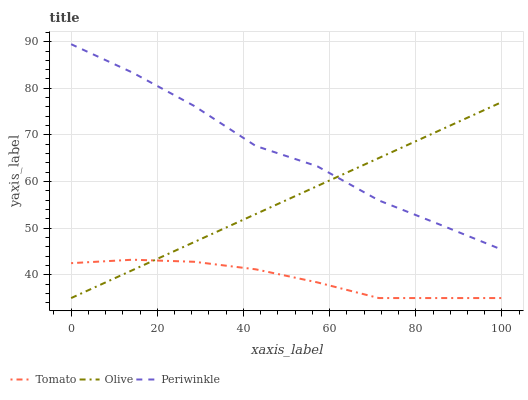Does Tomato have the minimum area under the curve?
Answer yes or no. Yes. Does Periwinkle have the maximum area under the curve?
Answer yes or no. Yes. Does Olive have the minimum area under the curve?
Answer yes or no. No. Does Olive have the maximum area under the curve?
Answer yes or no. No. Is Olive the smoothest?
Answer yes or no. Yes. Is Periwinkle the roughest?
Answer yes or no. Yes. Is Periwinkle the smoothest?
Answer yes or no. No. Is Olive the roughest?
Answer yes or no. No. Does Tomato have the lowest value?
Answer yes or no. Yes. Does Periwinkle have the lowest value?
Answer yes or no. No. Does Periwinkle have the highest value?
Answer yes or no. Yes. Does Olive have the highest value?
Answer yes or no. No. Is Tomato less than Periwinkle?
Answer yes or no. Yes. Is Periwinkle greater than Tomato?
Answer yes or no. Yes. Does Olive intersect Tomato?
Answer yes or no. Yes. Is Olive less than Tomato?
Answer yes or no. No. Is Olive greater than Tomato?
Answer yes or no. No. Does Tomato intersect Periwinkle?
Answer yes or no. No. 